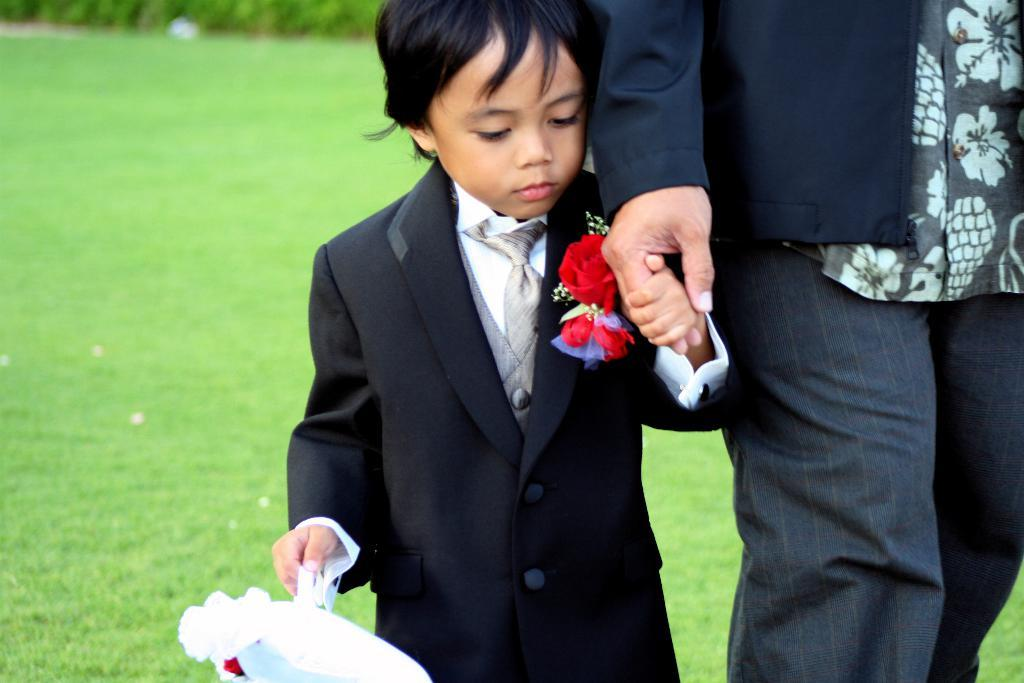What can be seen in the image? There are children in the image. How are the children interacting with each other? The children are holding hands. What type of surface is visible in the image? There is grass visible in the image. What type of church can be seen in the background of the image? There is no church present in the image; it only features children holding hands on a grassy surface. 